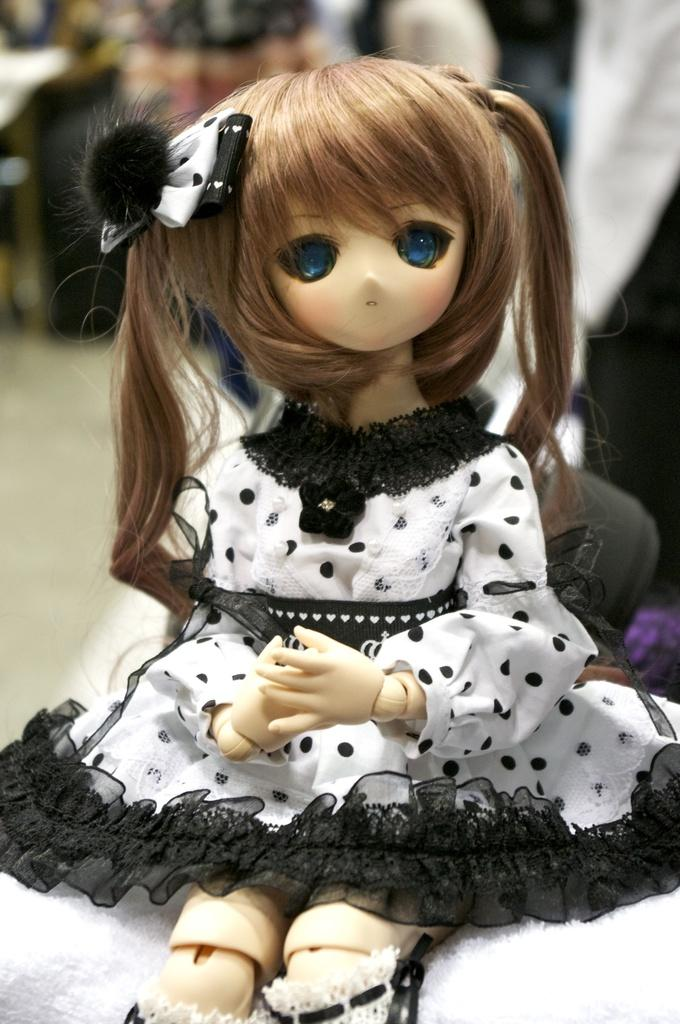What is present in the image? There is a doll in the image. What is the doll wearing? The doll is wearing a dress. Can you describe the objects behind the doll in the image? The objects behind the doll are blurred. What type of wood is the doll made of in the image? The image does not provide information about the material the doll is made of, so it cannot be determined from the picture. 